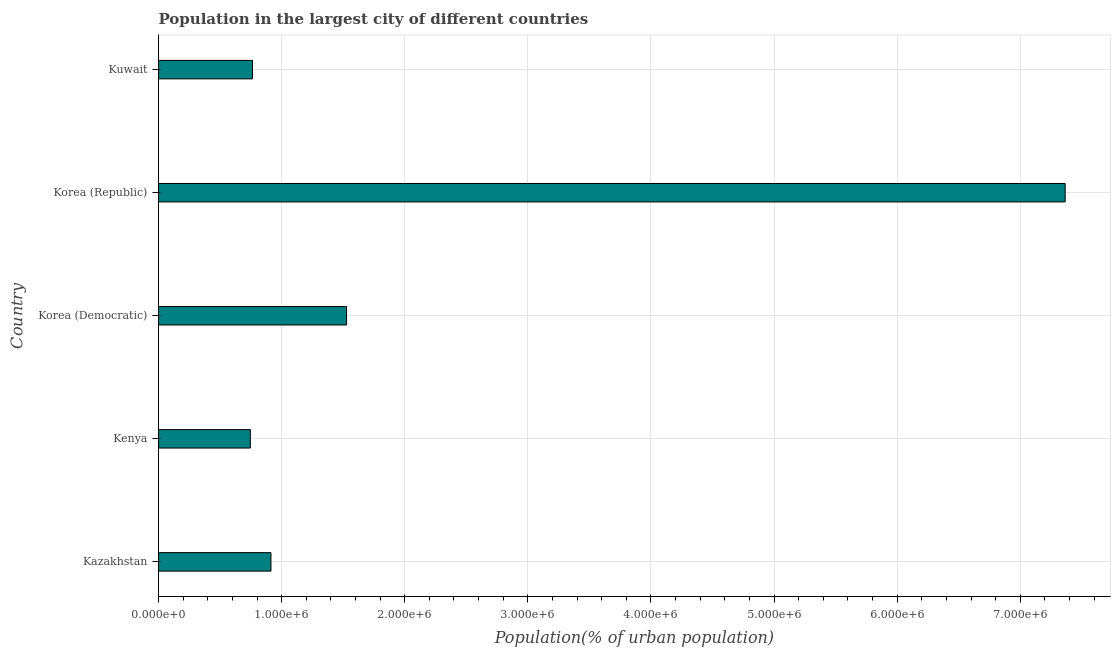Does the graph contain any zero values?
Ensure brevity in your answer.  No. What is the title of the graph?
Your response must be concise. Population in the largest city of different countries. What is the label or title of the X-axis?
Your response must be concise. Population(% of urban population). What is the population in largest city in Korea (Republic)?
Your answer should be compact. 7.36e+06. Across all countries, what is the maximum population in largest city?
Give a very brief answer. 7.36e+06. Across all countries, what is the minimum population in largest city?
Your answer should be compact. 7.46e+05. In which country was the population in largest city minimum?
Provide a succinct answer. Kenya. What is the sum of the population in largest city?
Ensure brevity in your answer.  1.13e+07. What is the difference between the population in largest city in Korea (Democratic) and Korea (Republic)?
Your answer should be very brief. -5.84e+06. What is the average population in largest city per country?
Make the answer very short. 2.26e+06. What is the median population in largest city?
Ensure brevity in your answer.  9.13e+05. In how many countries, is the population in largest city greater than 7000000 %?
Your answer should be compact. 1. What is the ratio of the population in largest city in Kenya to that in Korea (Republic)?
Offer a very short reply. 0.1. Is the population in largest city in Kenya less than that in Korea (Republic)?
Ensure brevity in your answer.  Yes. Is the difference between the population in largest city in Korea (Democratic) and Kuwait greater than the difference between any two countries?
Make the answer very short. No. What is the difference between the highest and the second highest population in largest city?
Your response must be concise. 5.84e+06. What is the difference between the highest and the lowest population in largest city?
Offer a terse response. 6.62e+06. How many bars are there?
Make the answer very short. 5. Are the values on the major ticks of X-axis written in scientific E-notation?
Provide a short and direct response. Yes. What is the Population(% of urban population) in Kazakhstan?
Provide a succinct answer. 9.13e+05. What is the Population(% of urban population) of Kenya?
Keep it short and to the point. 7.46e+05. What is the Population(% of urban population) of Korea (Democratic)?
Make the answer very short. 1.53e+06. What is the Population(% of urban population) in Korea (Republic)?
Your response must be concise. 7.36e+06. What is the Population(% of urban population) of Kuwait?
Provide a short and direct response. 7.63e+05. What is the difference between the Population(% of urban population) in Kazakhstan and Kenya?
Keep it short and to the point. 1.68e+05. What is the difference between the Population(% of urban population) in Kazakhstan and Korea (Democratic)?
Make the answer very short. -6.14e+05. What is the difference between the Population(% of urban population) in Kazakhstan and Korea (Republic)?
Offer a very short reply. -6.45e+06. What is the difference between the Population(% of urban population) in Kazakhstan and Kuwait?
Keep it short and to the point. 1.50e+05. What is the difference between the Population(% of urban population) in Kenya and Korea (Democratic)?
Offer a terse response. -7.82e+05. What is the difference between the Population(% of urban population) in Kenya and Korea (Republic)?
Ensure brevity in your answer.  -6.62e+06. What is the difference between the Population(% of urban population) in Kenya and Kuwait?
Ensure brevity in your answer.  -1.76e+04. What is the difference between the Population(% of urban population) in Korea (Democratic) and Korea (Republic)?
Provide a short and direct response. -5.84e+06. What is the difference between the Population(% of urban population) in Korea (Democratic) and Kuwait?
Your answer should be compact. 7.64e+05. What is the difference between the Population(% of urban population) in Korea (Republic) and Kuwait?
Provide a short and direct response. 6.60e+06. What is the ratio of the Population(% of urban population) in Kazakhstan to that in Kenya?
Keep it short and to the point. 1.23. What is the ratio of the Population(% of urban population) in Kazakhstan to that in Korea (Democratic)?
Provide a succinct answer. 0.6. What is the ratio of the Population(% of urban population) in Kazakhstan to that in Korea (Republic)?
Your response must be concise. 0.12. What is the ratio of the Population(% of urban population) in Kazakhstan to that in Kuwait?
Ensure brevity in your answer.  1.2. What is the ratio of the Population(% of urban population) in Kenya to that in Korea (Democratic)?
Ensure brevity in your answer.  0.49. What is the ratio of the Population(% of urban population) in Kenya to that in Korea (Republic)?
Offer a terse response. 0.1. What is the ratio of the Population(% of urban population) in Kenya to that in Kuwait?
Make the answer very short. 0.98. What is the ratio of the Population(% of urban population) in Korea (Democratic) to that in Korea (Republic)?
Offer a very short reply. 0.21. What is the ratio of the Population(% of urban population) in Korea (Democratic) to that in Kuwait?
Your response must be concise. 2. What is the ratio of the Population(% of urban population) in Korea (Republic) to that in Kuwait?
Give a very brief answer. 9.65. 